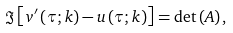Convert formula to latex. <formula><loc_0><loc_0><loc_500><loc_500>\Im \left [ v ^ { \prime } \left ( \tau ; k \right ) - u \left ( \tau ; k \right ) \right ] = \det \left ( A \right ) ,</formula> 